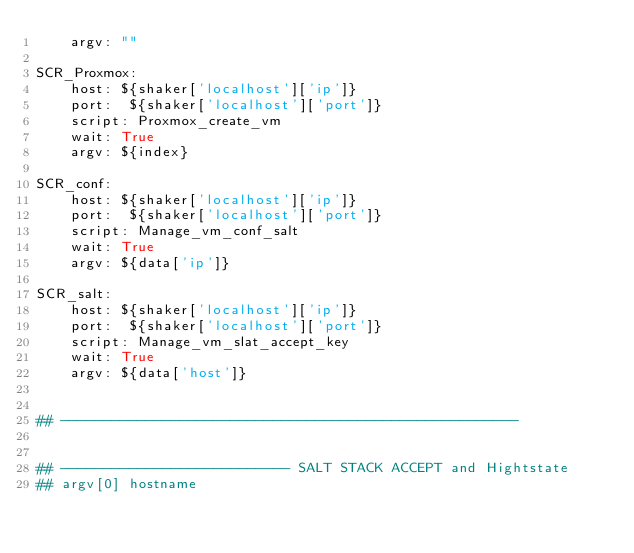Convert code to text. <code><loc_0><loc_0><loc_500><loc_500><_YAML_>    argv: ""

SCR_Proxmox:
    host: ${shaker['localhost']['ip']}
    port:  ${shaker['localhost']['port']}
    script: Proxmox_create_vm
    wait: True
    argv: ${index}

SCR_conf:
    host: ${shaker['localhost']['ip']}
    port:  ${shaker['localhost']['port']}
    script: Manage_vm_conf_salt
    wait: True
    argv: ${data['ip']}

SCR_salt:
    host: ${shaker['localhost']['ip']}
    port:  ${shaker['localhost']['port']}
    script: Manage_vm_slat_accept_key
    wait: True
    argv: ${data['host']}


## ------------------------------------------------------


## --------------------------- SALT STACK ACCEPT and Hightstate
## argv[0] hostname 

</code> 